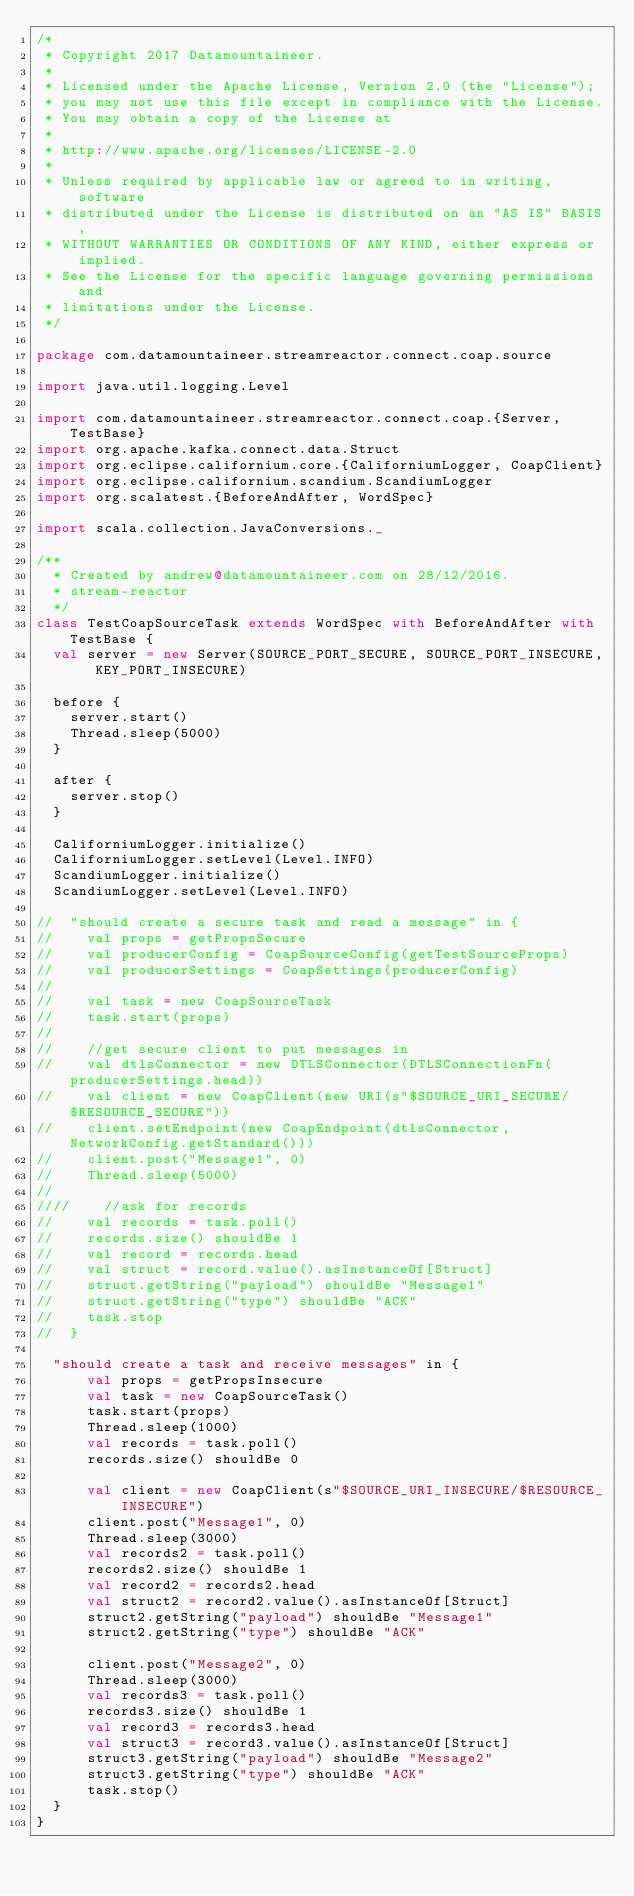<code> <loc_0><loc_0><loc_500><loc_500><_Scala_>/*
 * Copyright 2017 Datamountaineer.
 *
 * Licensed under the Apache License, Version 2.0 (the "License");
 * you may not use this file except in compliance with the License.
 * You may obtain a copy of the License at
 *
 * http://www.apache.org/licenses/LICENSE-2.0
 *
 * Unless required by applicable law or agreed to in writing, software
 * distributed under the License is distributed on an "AS IS" BASIS,
 * WITHOUT WARRANTIES OR CONDITIONS OF ANY KIND, either express or implied.
 * See the License for the specific language governing permissions and
 * limitations under the License.
 */

package com.datamountaineer.streamreactor.connect.coap.source

import java.util.logging.Level

import com.datamountaineer.streamreactor.connect.coap.{Server, TestBase}
import org.apache.kafka.connect.data.Struct
import org.eclipse.californium.core.{CaliforniumLogger, CoapClient}
import org.eclipse.californium.scandium.ScandiumLogger
import org.scalatest.{BeforeAndAfter, WordSpec}

import scala.collection.JavaConversions._

/**
  * Created by andrew@datamountaineer.com on 28/12/2016. 
  * stream-reactor
  */
class TestCoapSourceTask extends WordSpec with BeforeAndAfter with TestBase {
  val server = new Server(SOURCE_PORT_SECURE, SOURCE_PORT_INSECURE, KEY_PORT_INSECURE)

  before {
    server.start()
    Thread.sleep(5000)
  }

  after {
    server.stop()
  }

  CaliforniumLogger.initialize()
  CaliforniumLogger.setLevel(Level.INFO)
  ScandiumLogger.initialize()
  ScandiumLogger.setLevel(Level.INFO)

//  "should create a secure task and read a message" in {
//    val props = getPropsSecure
//    val producerConfig = CoapSourceConfig(getTestSourceProps)
//    val producerSettings = CoapSettings(producerConfig)
//
//    val task = new CoapSourceTask
//    task.start(props)
//
//    //get secure client to put messages in
//    val dtlsConnector = new DTLSConnector(DTLSConnectionFn(producerSettings.head))
//    val client = new CoapClient(new URI(s"$SOURCE_URI_SECURE/$RESOURCE_SECURE"))
//    client.setEndpoint(new CoapEndpoint(dtlsConnector, NetworkConfig.getStandard()))
//    client.post("Message1", 0)
//    Thread.sleep(5000)
//
////    //ask for records
//    val records = task.poll()
//    records.size() shouldBe 1
//    val record = records.head
//    val struct = record.value().asInstanceOf[Struct]
//    struct.getString("payload") shouldBe "Message1"
//    struct.getString("type") shouldBe "ACK"
//    task.stop
//  }

  "should create a task and receive messages" in {
      val props = getPropsInsecure
      val task = new CoapSourceTask()
      task.start(props)
      Thread.sleep(1000)
      val records = task.poll()
      records.size() shouldBe 0

      val client = new CoapClient(s"$SOURCE_URI_INSECURE/$RESOURCE_INSECURE")
      client.post("Message1", 0)
      Thread.sleep(3000)
      val records2 = task.poll()
      records2.size() shouldBe 1
      val record2 = records2.head
      val struct2 = record2.value().asInstanceOf[Struct]
      struct2.getString("payload") shouldBe "Message1"
      struct2.getString("type") shouldBe "ACK"

      client.post("Message2", 0)
      Thread.sleep(3000)
      val records3 = task.poll()
      records3.size() shouldBe 1
      val record3 = records3.head
      val struct3 = record3.value().asInstanceOf[Struct]
      struct3.getString("payload") shouldBe "Message2"
      struct3.getString("type") shouldBe "ACK"
      task.stop()
  }
}
</code> 